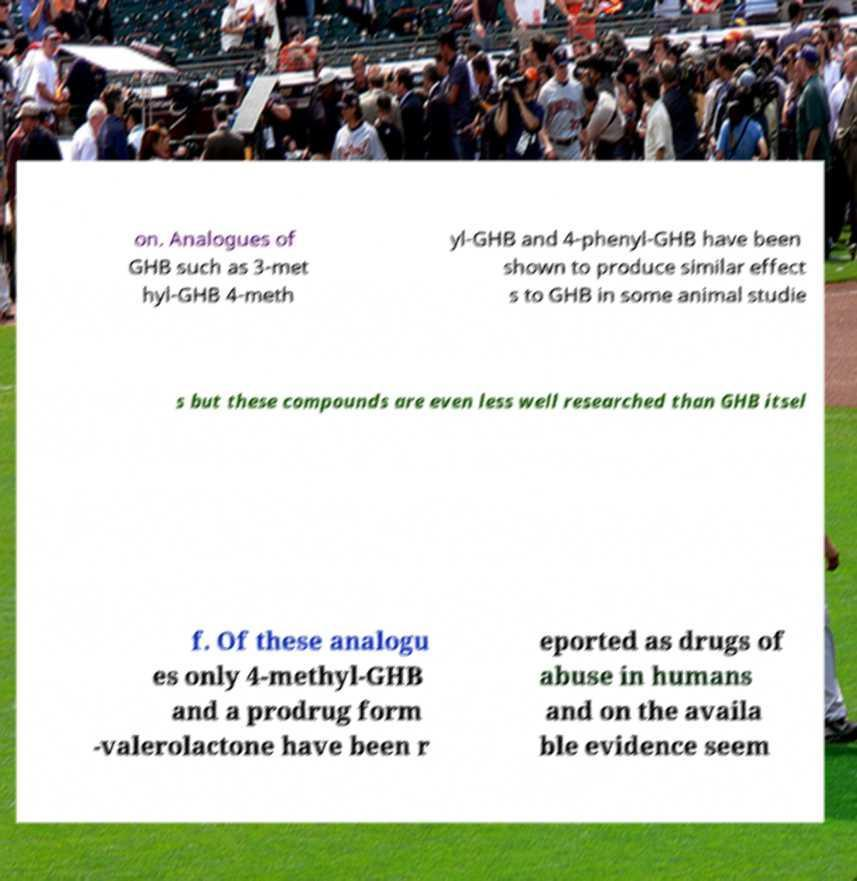I need the written content from this picture converted into text. Can you do that? on. Analogues of GHB such as 3-met hyl-GHB 4-meth yl-GHB and 4-phenyl-GHB have been shown to produce similar effect s to GHB in some animal studie s but these compounds are even less well researched than GHB itsel f. Of these analogu es only 4-methyl-GHB and a prodrug form -valerolactone have been r eported as drugs of abuse in humans and on the availa ble evidence seem 